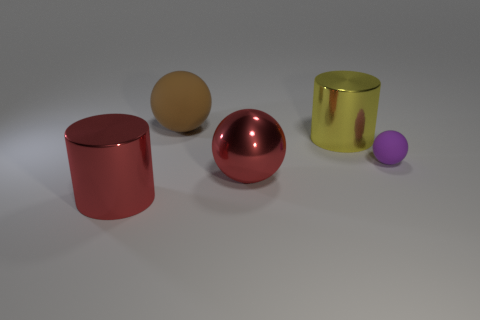Add 2 brown matte things. How many objects exist? 7 Subtract all big metal spheres. How many spheres are left? 2 Subtract 1 balls. How many balls are left? 2 Subtract all cylinders. How many objects are left? 3 Add 5 small purple blocks. How many small purple blocks exist? 5 Subtract 0 red cubes. How many objects are left? 5 Subtract all green balls. Subtract all green cubes. How many balls are left? 3 Subtract all large red cylinders. Subtract all large yellow metal objects. How many objects are left? 3 Add 5 big red objects. How many big red objects are left? 7 